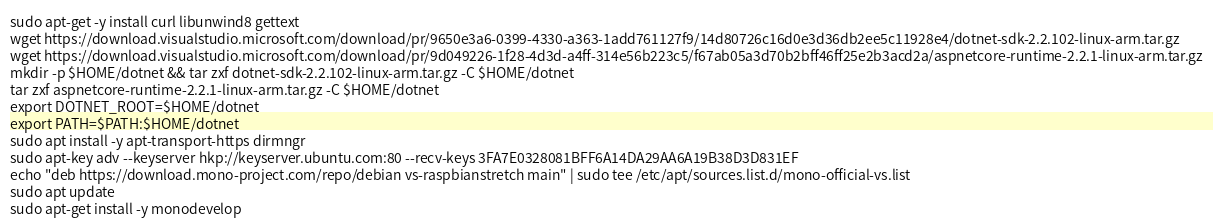<code> <loc_0><loc_0><loc_500><loc_500><_Bash_>sudo apt-get -y install curl libunwind8 gettext
wget https://download.visualstudio.microsoft.com/download/pr/9650e3a6-0399-4330-a363-1add761127f9/14d80726c16d0e3d36db2ee5c11928e4/dotnet-sdk-2.2.102-linux-arm.tar.gz
wget https://download.visualstudio.microsoft.com/download/pr/9d049226-1f28-4d3d-a4ff-314e56b223c5/f67ab05a3d70b2bff46ff25e2b3acd2a/aspnetcore-runtime-2.2.1-linux-arm.tar.gz
mkdir -p $HOME/dotnet && tar zxf dotnet-sdk-2.2.102-linux-arm.tar.gz -C $HOME/dotnet
tar zxf aspnetcore-runtime-2.2.1-linux-arm.tar.gz -C $HOME/dotnet
export DOTNET_ROOT=$HOME/dotnet 
export PATH=$PATH:$HOME/dotnet
sudo apt install -y apt-transport-https dirmngr
sudo apt-key adv --keyserver hkp://keyserver.ubuntu.com:80 --recv-keys 3FA7E0328081BFF6A14DA29AA6A19B38D3D831EF
echo "deb https://download.mono-project.com/repo/debian vs-raspbianstretch main" | sudo tee /etc/apt/sources.list.d/mono-official-vs.list
sudo apt update
sudo apt-get install -y monodevelop
</code> 